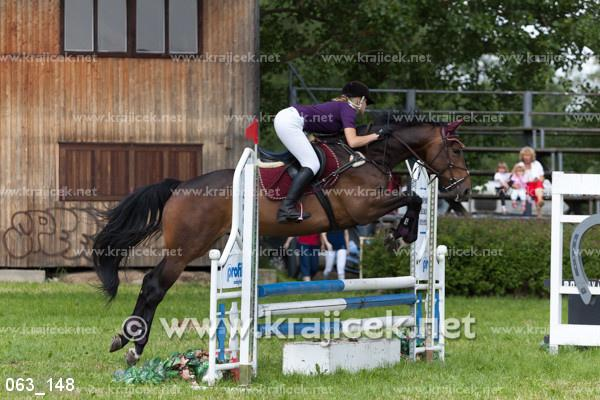What activity is the horse shown here taking part in?

Choices:
A) steeple chase
B) racing
C) barrel racing
D) roping steeple chase 